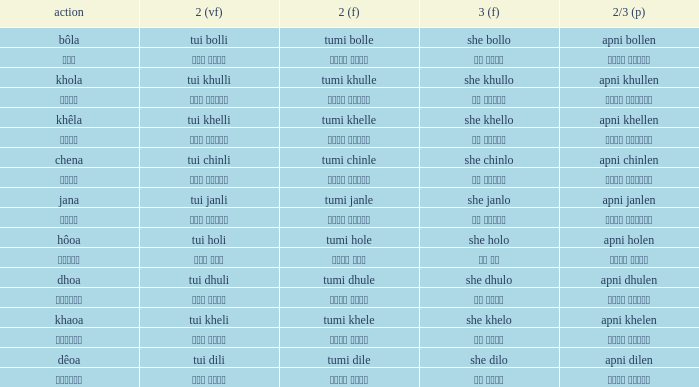What is the 2nd verb for chena? Tumi chinle. 